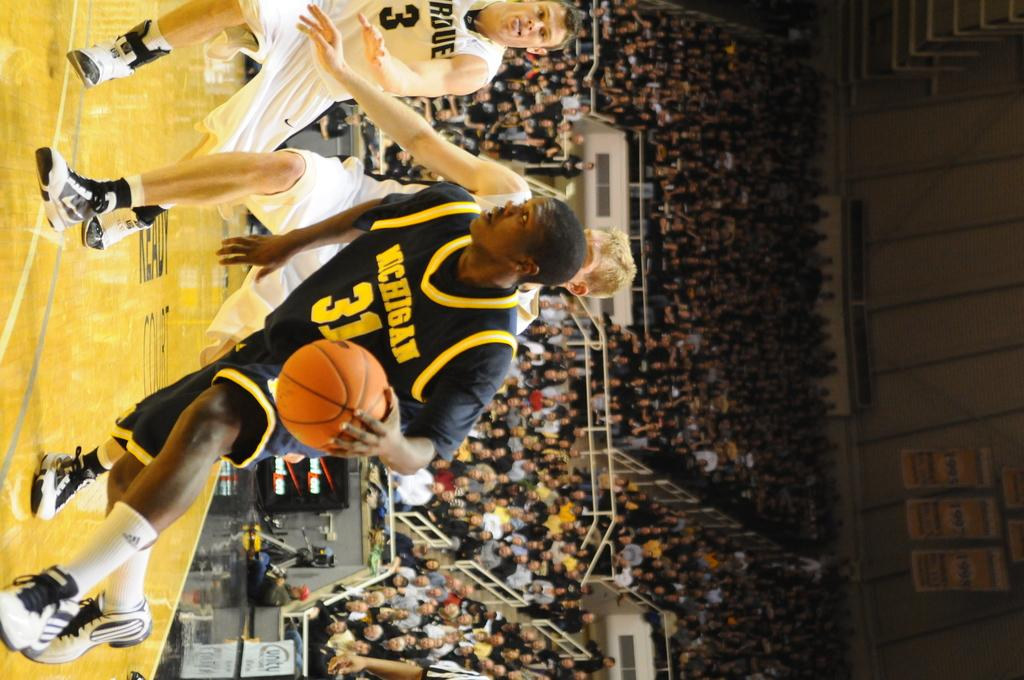What are the three men in the image doing? The three men in the image are running. What is the man holding in his hand? The man is holding a ball in his hand. What can be seen in the background of the image? There is a group of people sitting in the background, and banners are present as well. What type of record can be seen being played on a turntable in the image? There is no turntable or record present in the image; it features three men running and a man holding a ball. What type of comb is being used by the man in the image? There is no comb present in the image; it features three men running and a man holding a ball. 